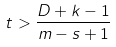Convert formula to latex. <formula><loc_0><loc_0><loc_500><loc_500>t > \frac { D + k - 1 } { m - s + 1 }</formula> 